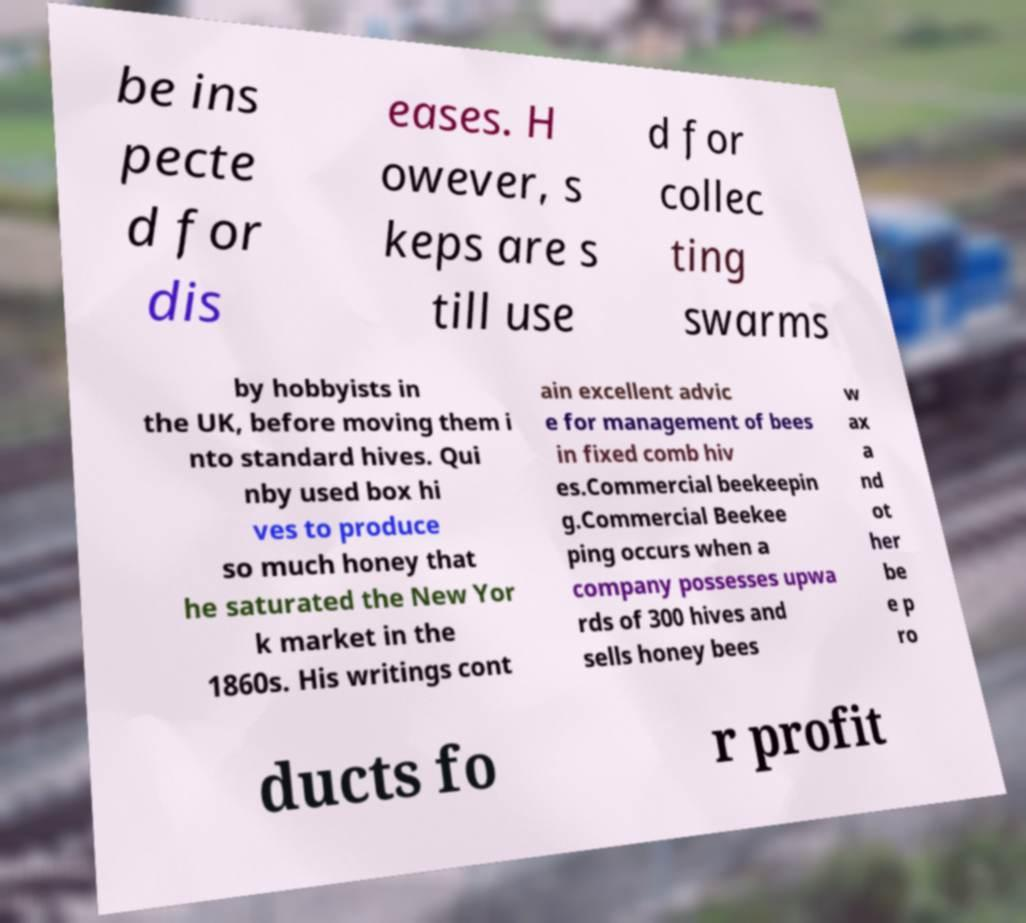For documentation purposes, I need the text within this image transcribed. Could you provide that? be ins pecte d for dis eases. H owever, s keps are s till use d for collec ting swarms by hobbyists in the UK, before moving them i nto standard hives. Qui nby used box hi ves to produce so much honey that he saturated the New Yor k market in the 1860s. His writings cont ain excellent advic e for management of bees in fixed comb hiv es.Commercial beekeepin g.Commercial Beekee ping occurs when a company possesses upwa rds of 300 hives and sells honey bees w ax a nd ot her be e p ro ducts fo r profit 